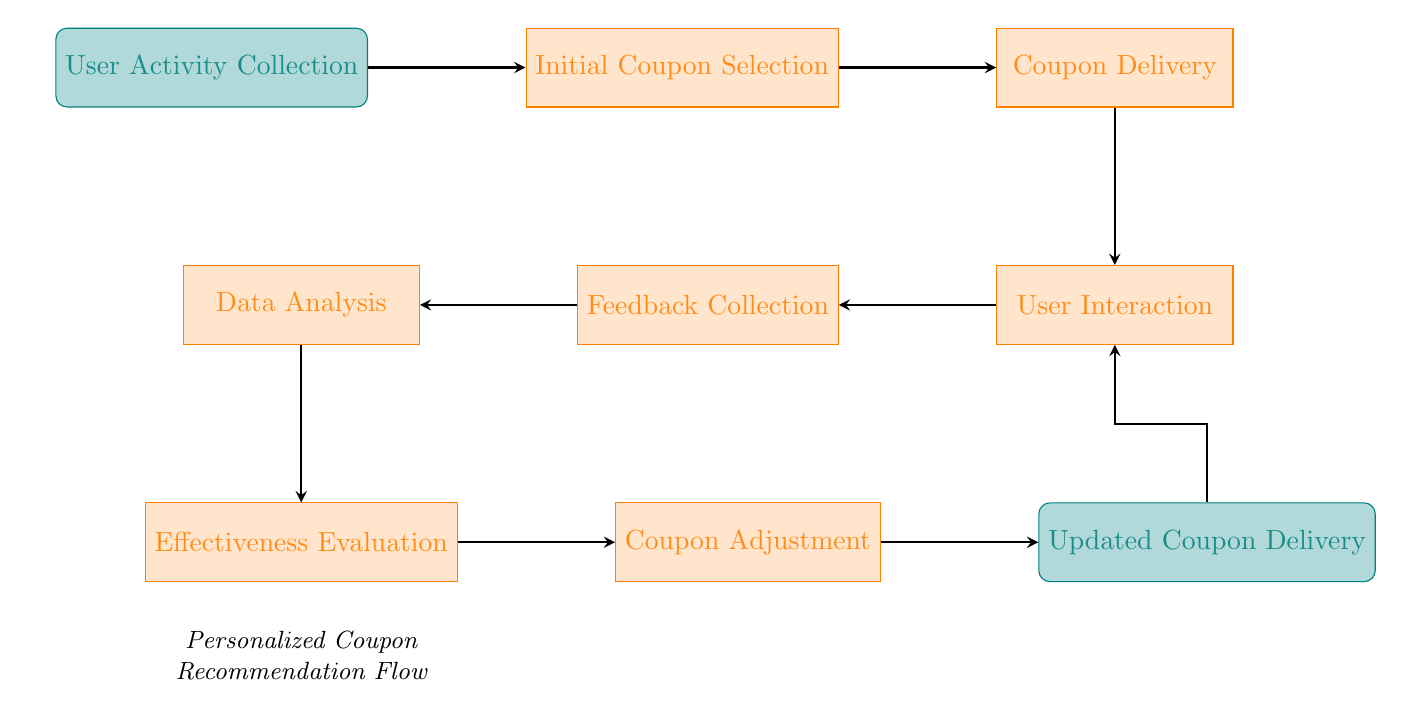What is the starting node of the flow? The diagram begins with the "User Activity Collection" node, which is the first action in the process.
Answer: User Activity Collection How many nodes are present in the diagram? By counting all the unique nodes listed, there are a total of nine nodes shown.
Answer: 9 Which node follows "Coupon Delivery"? The node that comes directly after "Coupon Delivery" in the flow is "User Interaction", indicating the subsequent action taken.
Answer: User Interaction What is the final node in the flowchart? The last node in the flow is labeled "Updated Coupon Delivery", signifying the end of the process.
Answer: Updated Coupon Delivery Which process is evaluated after Data Analysis? According to the sequence, the process that follows Data Analysis is the "Effectiveness Evaluation", where the results are assessed.
Answer: Effectiveness Evaluation How many arrows connect the nodes? There are a total of eight arrows indicating connections between the nodes, demonstrating the flow of actions within the chart.
Answer: 8 What action is taken after Feedback Collection? The next action taken after Feedback Collection is "Data Analysis", where the feedback is processed for further insights.
Answer: Data Analysis Which two nodes are connected directly by an arrow after Coupon Adjustment? The nodes connected by an arrow directly after Coupon Adjustment are "Updated Coupon Delivery", indicating the completion of the coupon adjustment process.
Answer: Updated Coupon Delivery How does the flow return to User Interaction after Updated Coupon Delivery? The flow returns to User Interaction via an arrow that indicates a feedback loop, demonstrating continual interaction and adjustments based on user responses.
Answer: Feedback loop 